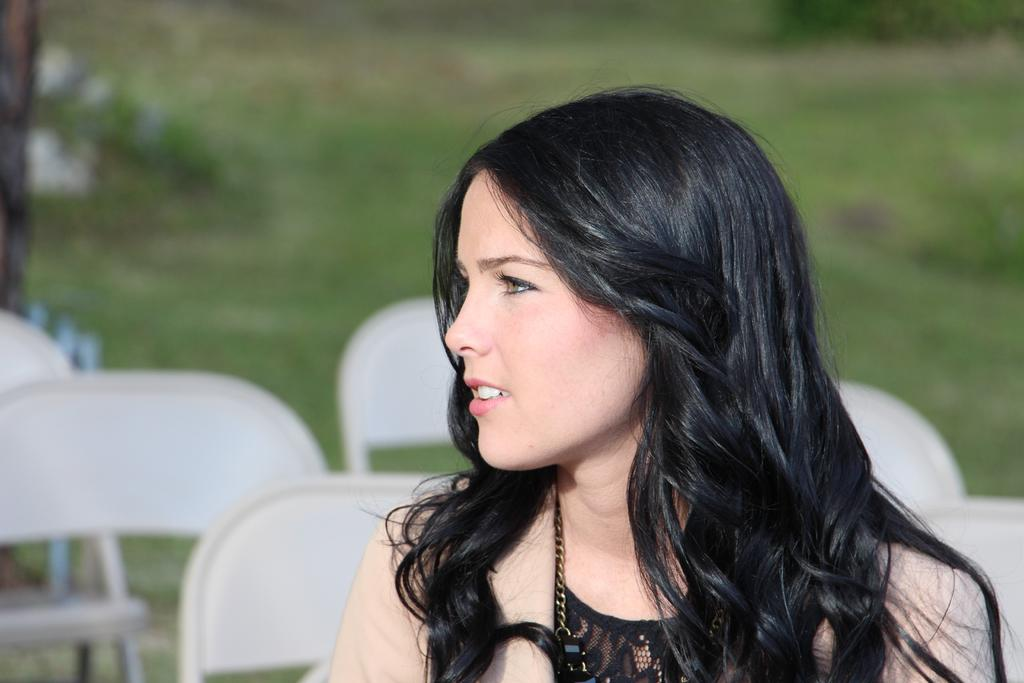Who is present in the image? There is a woman in the image. What type of furniture can be seen in the image? There are chairs in the image. Can you describe the background of the image? The background of the image is blurred. How many eggs are on the self in the image? There are no eggs or self present in the image. What act is the woman performing in the image? The image does not show the woman performing any specific act. 